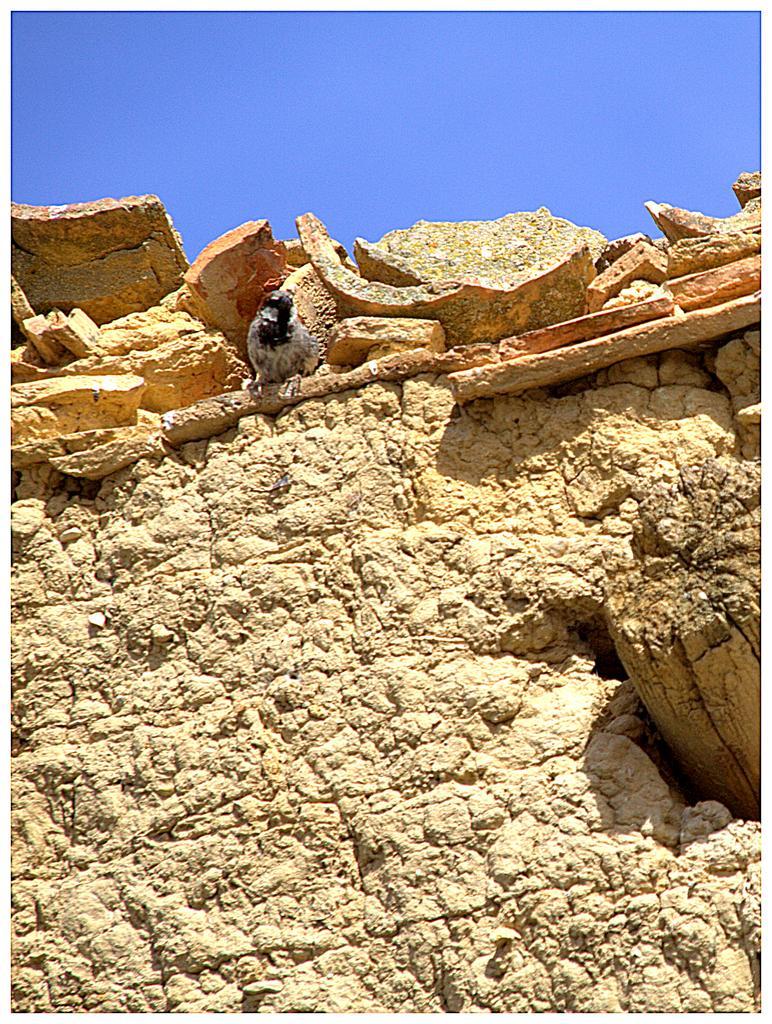Could you give a brief overview of what you see in this image? In this image we can see a bird on the wall, also we can the sky, rocks, and a wood. 